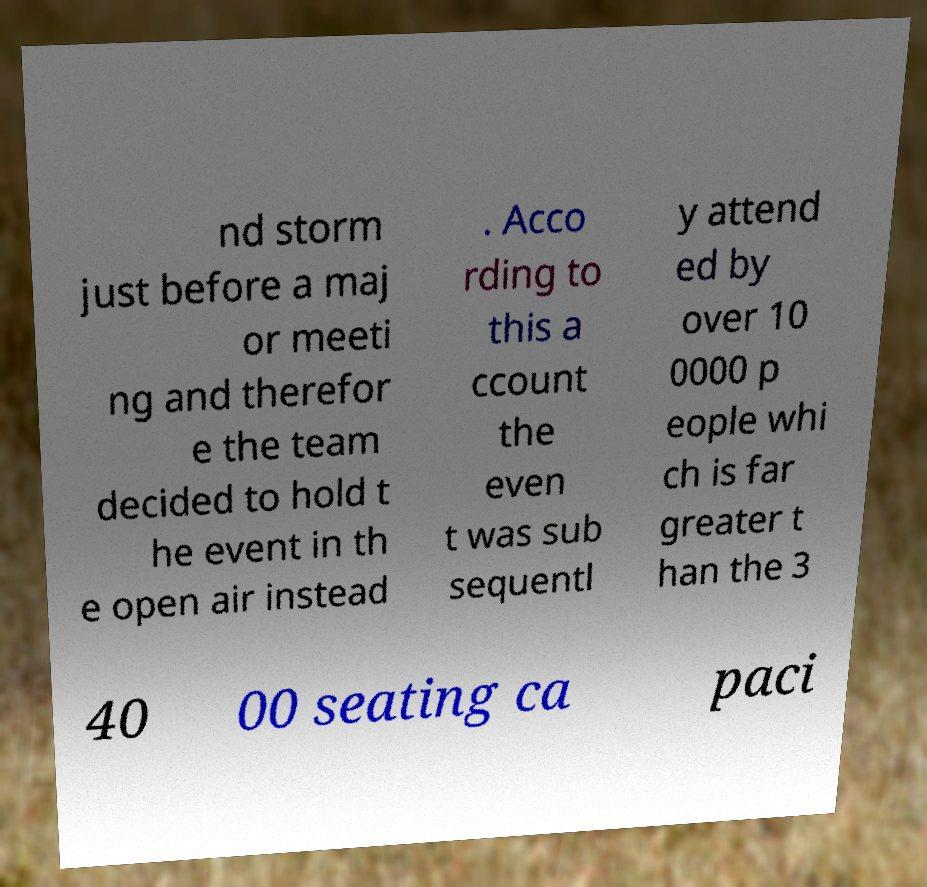Could you assist in decoding the text presented in this image and type it out clearly? nd storm just before a maj or meeti ng and therefor e the team decided to hold t he event in th e open air instead . Acco rding to this a ccount the even t was sub sequentl y attend ed by over 10 0000 p eople whi ch is far greater t han the 3 40 00 seating ca paci 